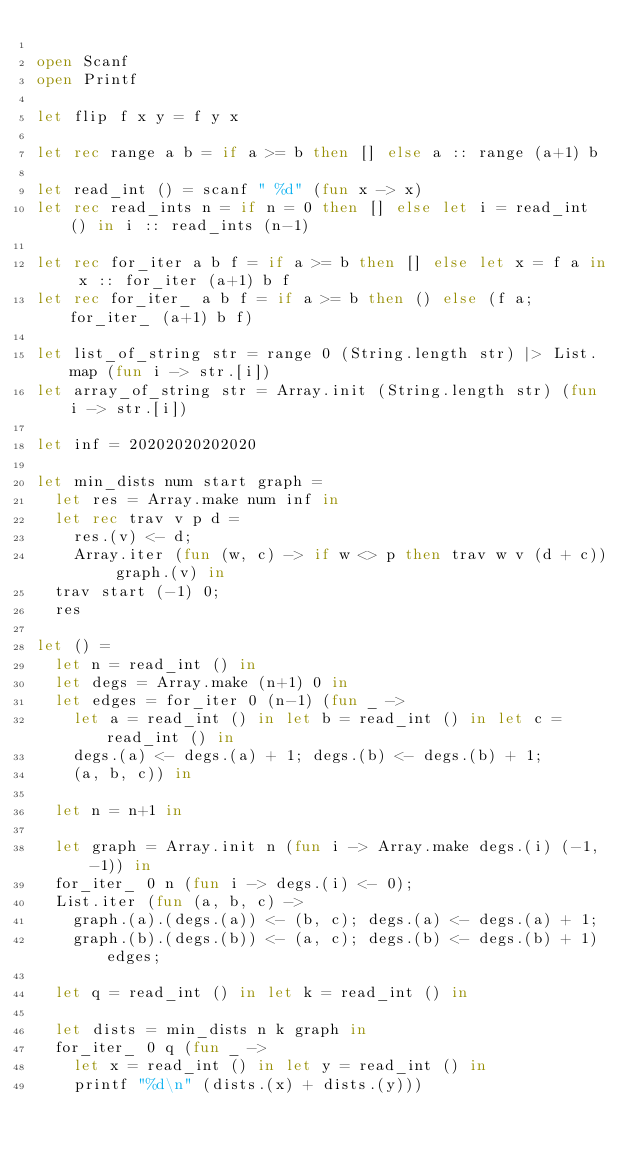Convert code to text. <code><loc_0><loc_0><loc_500><loc_500><_OCaml_>
open Scanf
open Printf

let flip f x y = f y x

let rec range a b = if a >= b then [] else a :: range (a+1) b

let read_int () = scanf " %d" (fun x -> x)
let rec read_ints n = if n = 0 then [] else let i = read_int () in i :: read_ints (n-1)

let rec for_iter a b f = if a >= b then [] else let x = f a in x :: for_iter (a+1) b f
let rec for_iter_ a b f = if a >= b then () else (f a; for_iter_ (a+1) b f)

let list_of_string str = range 0 (String.length str) |> List.map (fun i -> str.[i])
let array_of_string str = Array.init (String.length str) (fun i -> str.[i])

let inf = 20202020202020

let min_dists num start graph =
  let res = Array.make num inf in
  let rec trav v p d =
    res.(v) <- d;
    Array.iter (fun (w, c) -> if w <> p then trav w v (d + c)) graph.(v) in
  trav start (-1) 0;
  res

let () =
  let n = read_int () in
  let degs = Array.make (n+1) 0 in
  let edges = for_iter 0 (n-1) (fun _ ->
    let a = read_int () in let b = read_int () in let c = read_int () in
    degs.(a) <- degs.(a) + 1; degs.(b) <- degs.(b) + 1;
    (a, b, c)) in

  let n = n+1 in

  let graph = Array.init n (fun i -> Array.make degs.(i) (-1, -1)) in
  for_iter_ 0 n (fun i -> degs.(i) <- 0);
  List.iter (fun (a, b, c) ->
    graph.(a).(degs.(a)) <- (b, c); degs.(a) <- degs.(a) + 1;
    graph.(b).(degs.(b)) <- (a, c); degs.(b) <- degs.(b) + 1) edges;

  let q = read_int () in let k = read_int () in

  let dists = min_dists n k graph in
  for_iter_ 0 q (fun _ ->
    let x = read_int () in let y = read_int () in
    printf "%d\n" (dists.(x) + dists.(y)))
</code> 